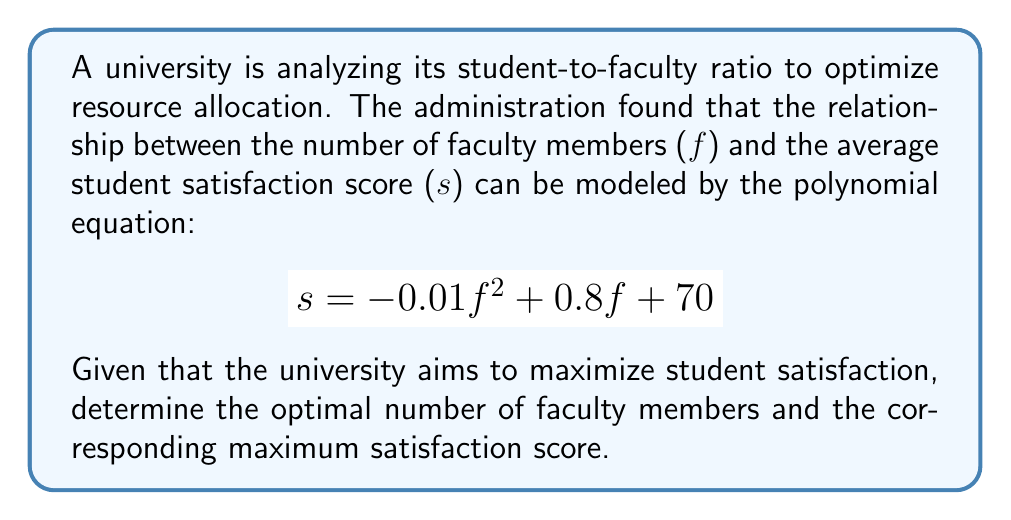Teach me how to tackle this problem. To find the optimal number of faculty members and maximum satisfaction score, we need to find the vertex of the parabola represented by the given quadratic equation. Here's how we can solve this step-by-step:

1) The equation is in the form $s = af^2 + bf + c$, where:
   $a = -0.01$
   $b = 0.8$
   $c = 70$

2) For a quadratic function, the f-coordinate of the vertex is given by $f = -\frac{b}{2a}$:

   $$f = -\frac{0.8}{2(-0.01)} = -\frac{0.8}{-0.02} = 40$$

3) To find the maximum satisfaction score, we substitute this f-value back into the original equation:

   $$s = -0.01(40)^2 + 0.8(40) + 70$$
   $$s = -0.01(1600) + 32 + 70$$
   $$s = -16 + 32 + 70$$
   $$s = 86$$

4) Therefore, the optimal number of faculty members is 40, and the maximum satisfaction score is 86.

This solution suggests that to maximize student satisfaction, the university should aim for a faculty size of 40 members, which would result in a peak satisfaction score of 86.
Answer: 40 faculty members; 86 satisfaction score 